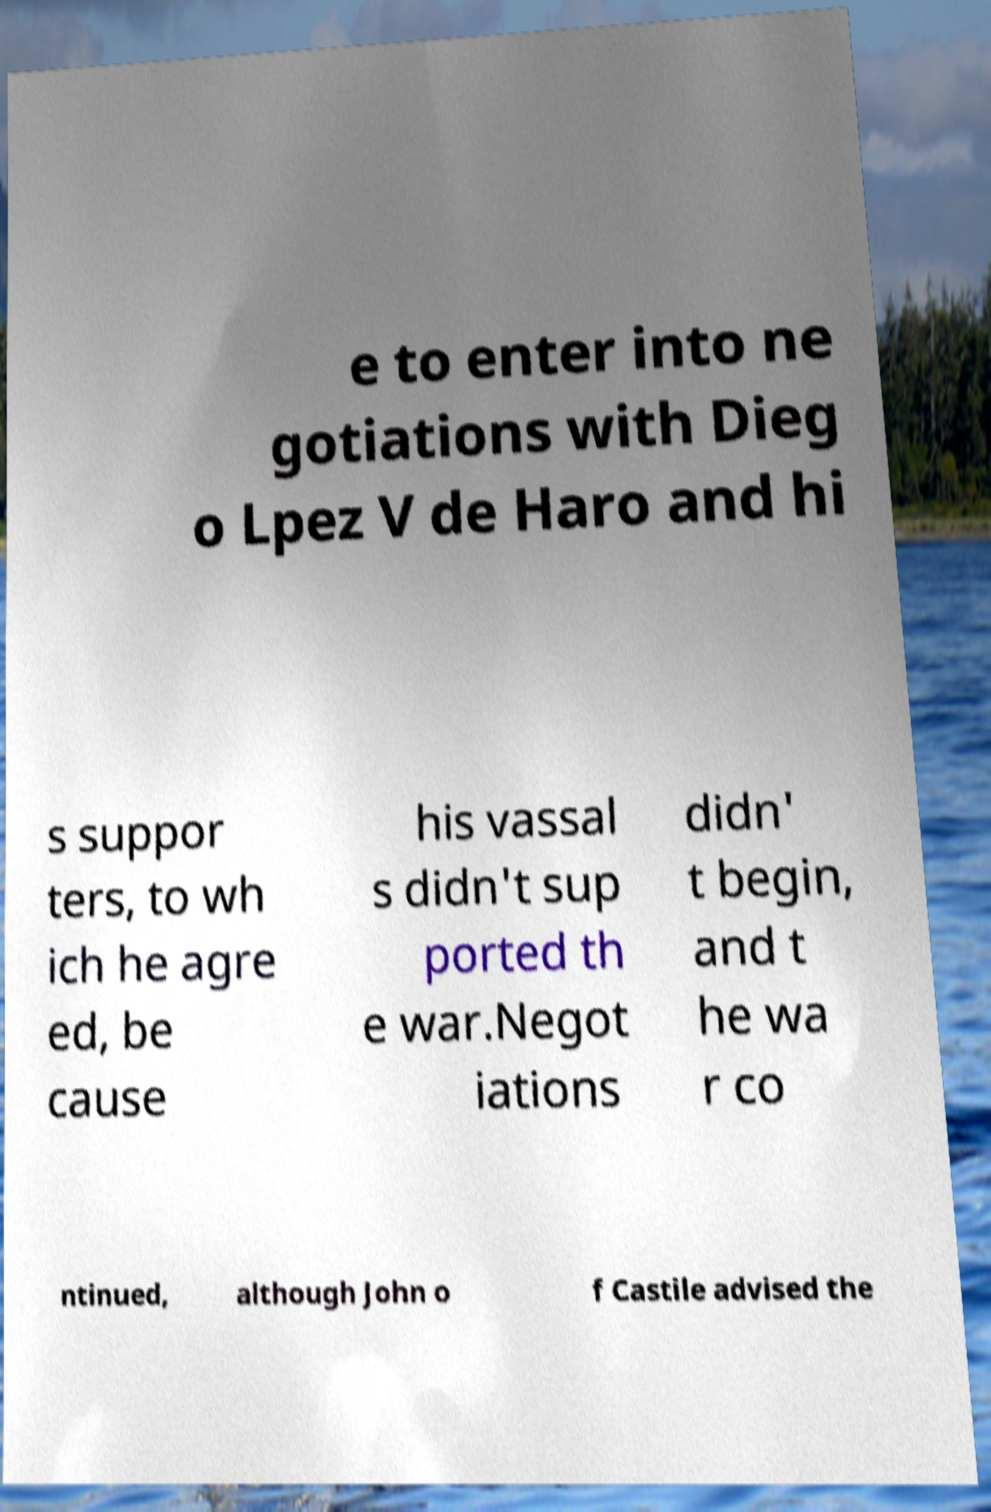Can you accurately transcribe the text from the provided image for me? e to enter into ne gotiations with Dieg o Lpez V de Haro and hi s suppor ters, to wh ich he agre ed, be cause his vassal s didn't sup ported th e war.Negot iations didn' t begin, and t he wa r co ntinued, although John o f Castile advised the 